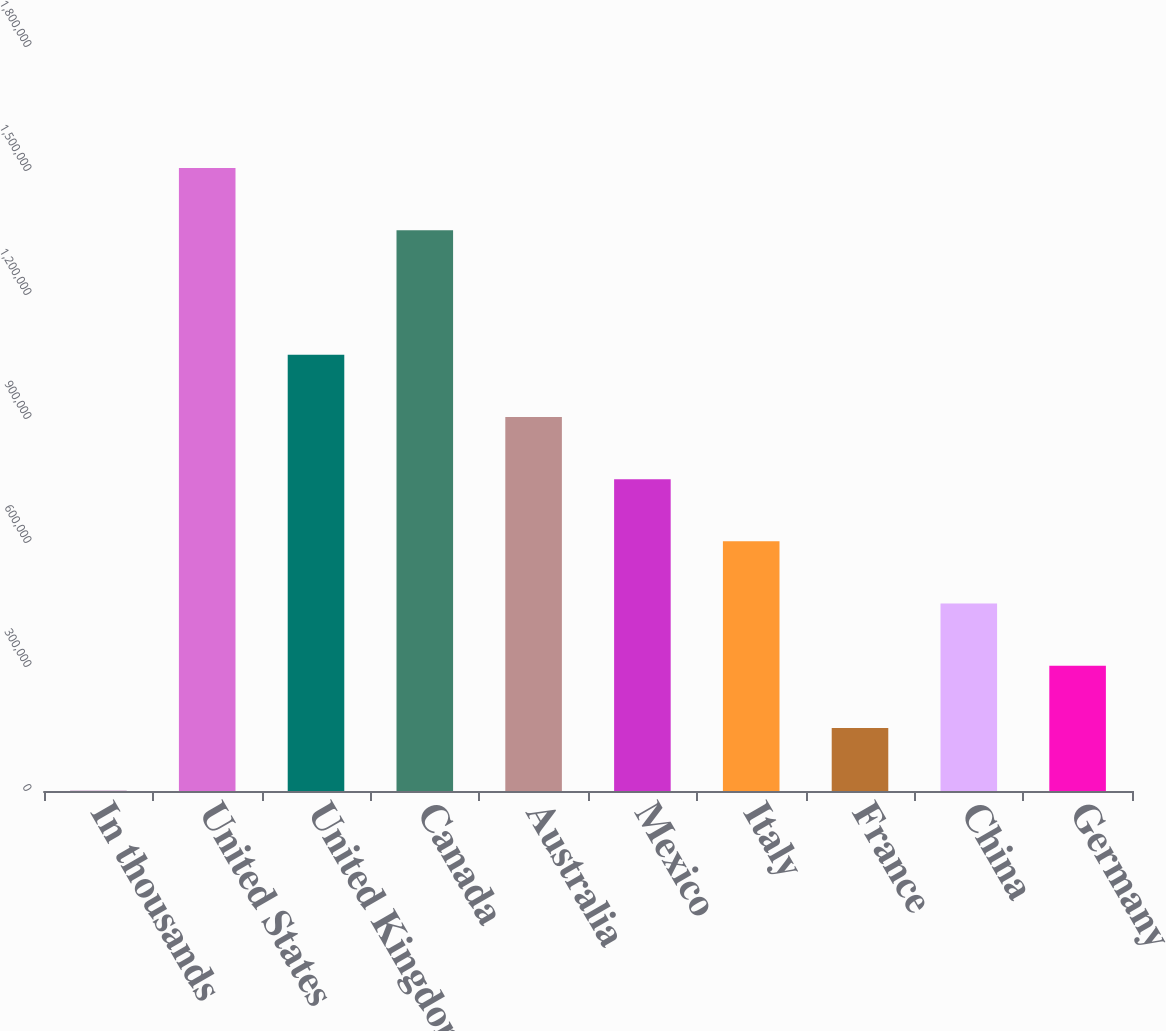<chart> <loc_0><loc_0><loc_500><loc_500><bar_chart><fcel>In thousands<fcel>United States<fcel>United Kingdom<fcel>Canada<fcel>Australia<fcel>Mexico<fcel>Italy<fcel>France<fcel>China<fcel>Germany<nl><fcel>2010<fcel>1.50701e+06<fcel>1.05551e+06<fcel>1.35651e+06<fcel>905011<fcel>754511<fcel>604011<fcel>152510<fcel>453511<fcel>303010<nl></chart> 